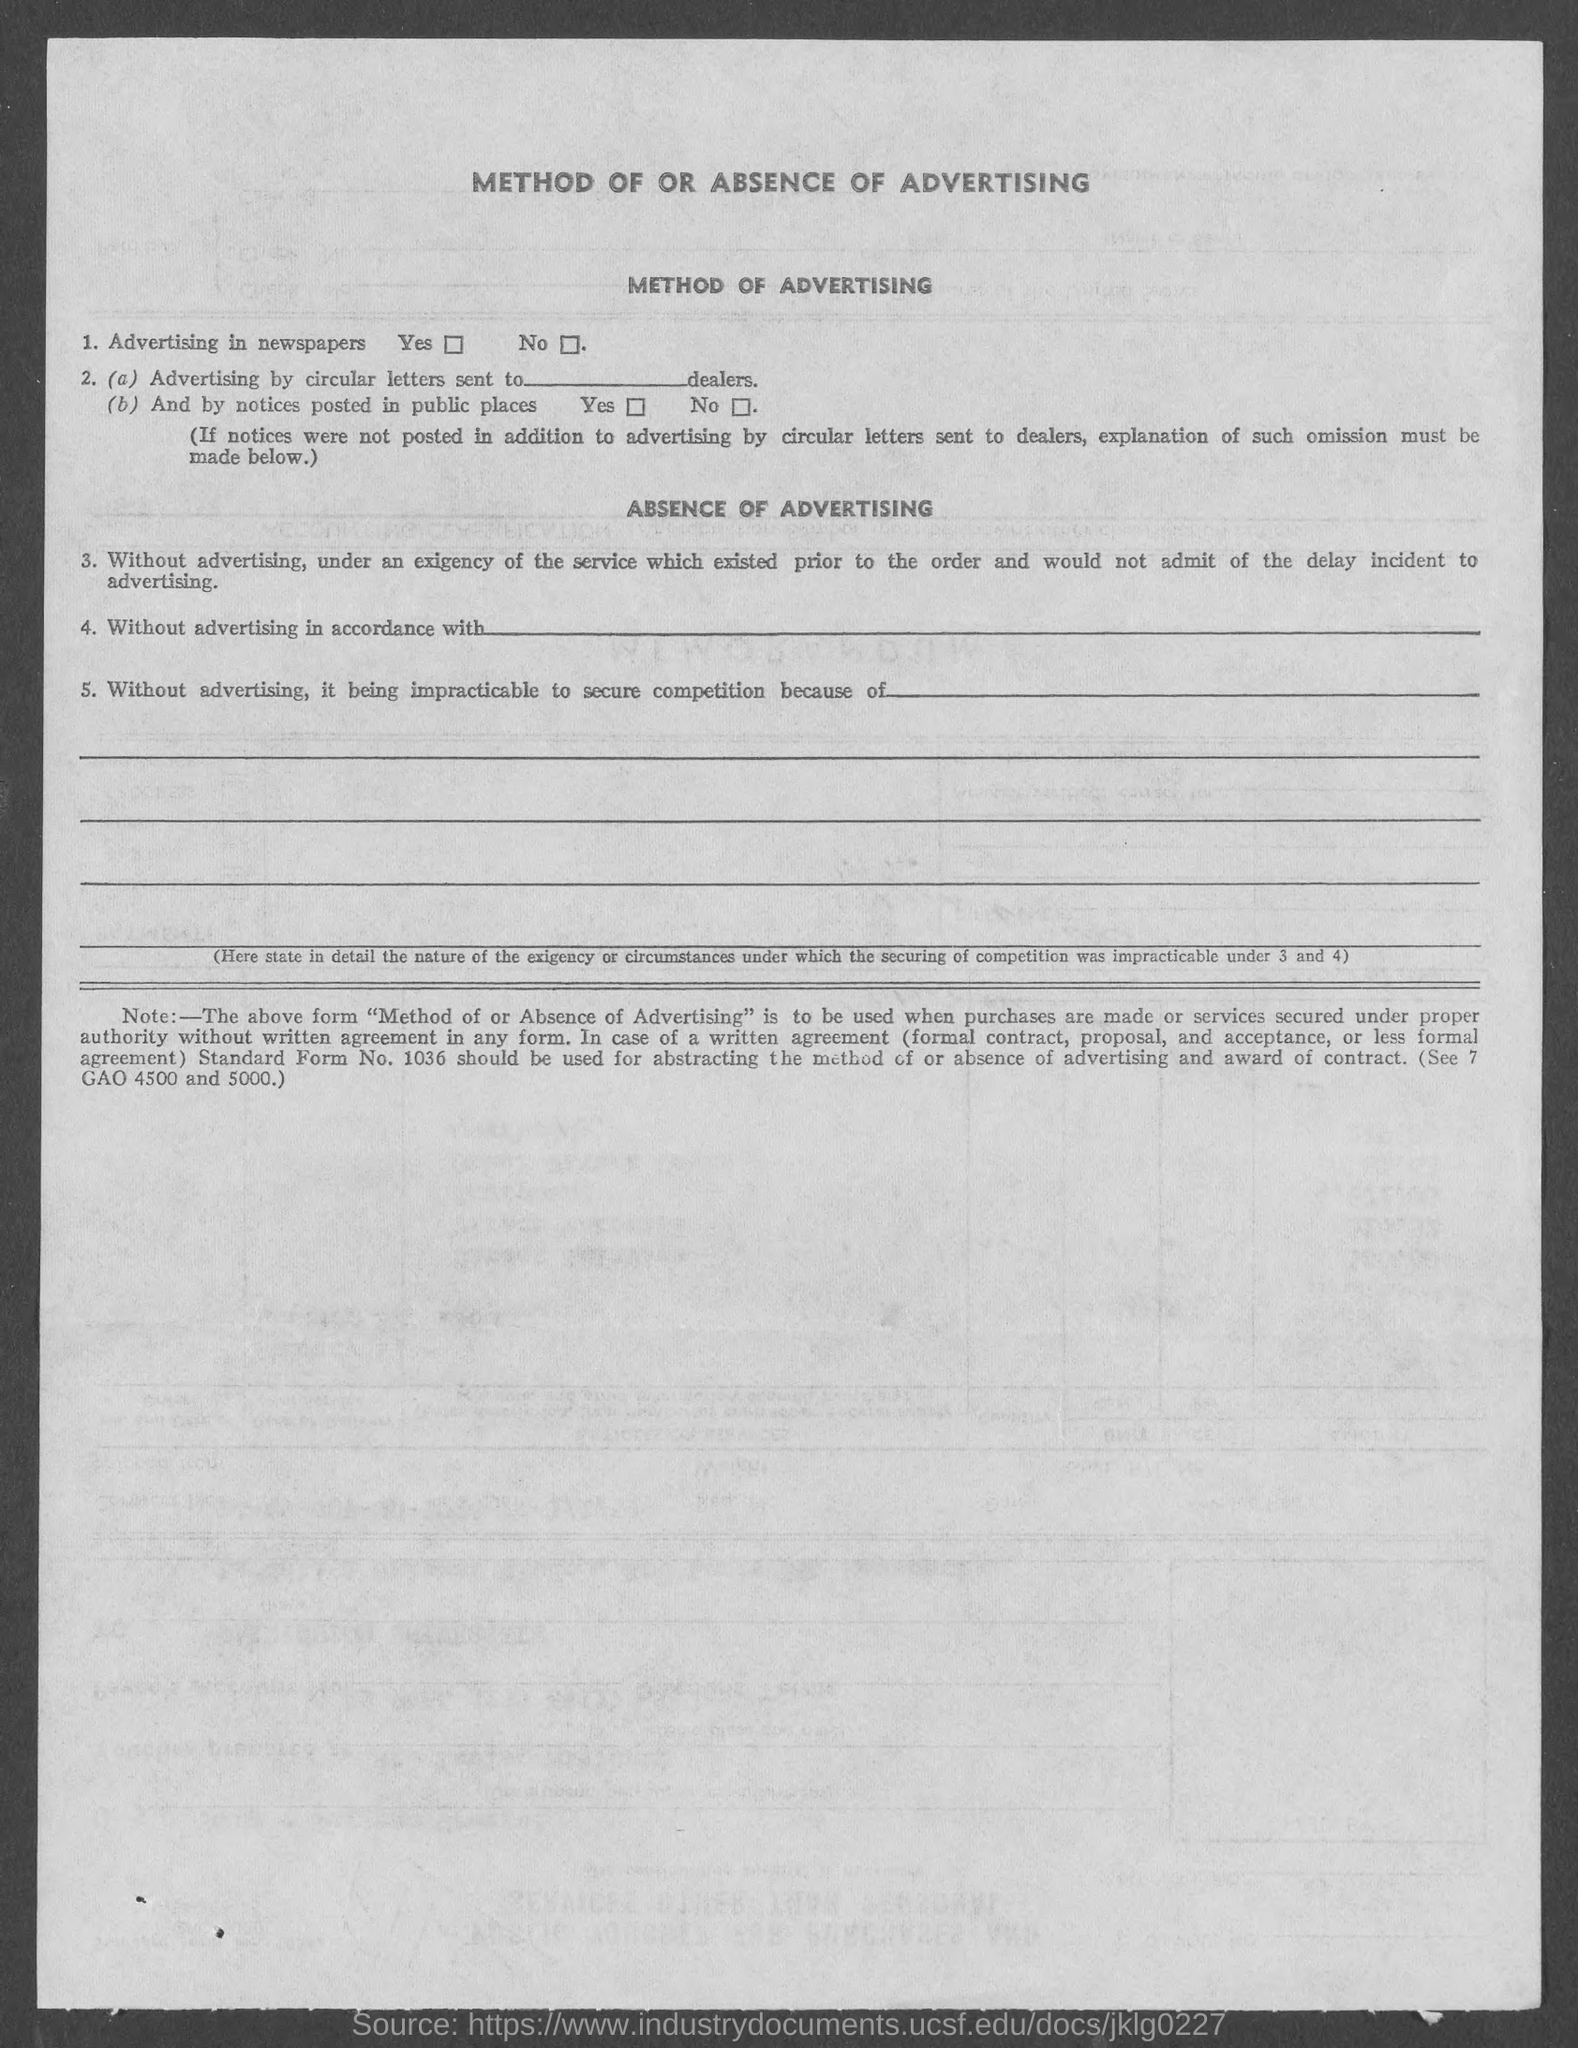Draw attention to some important aspects in this diagram. The heading at the top of the page is about the method of or the absence of advertising. 